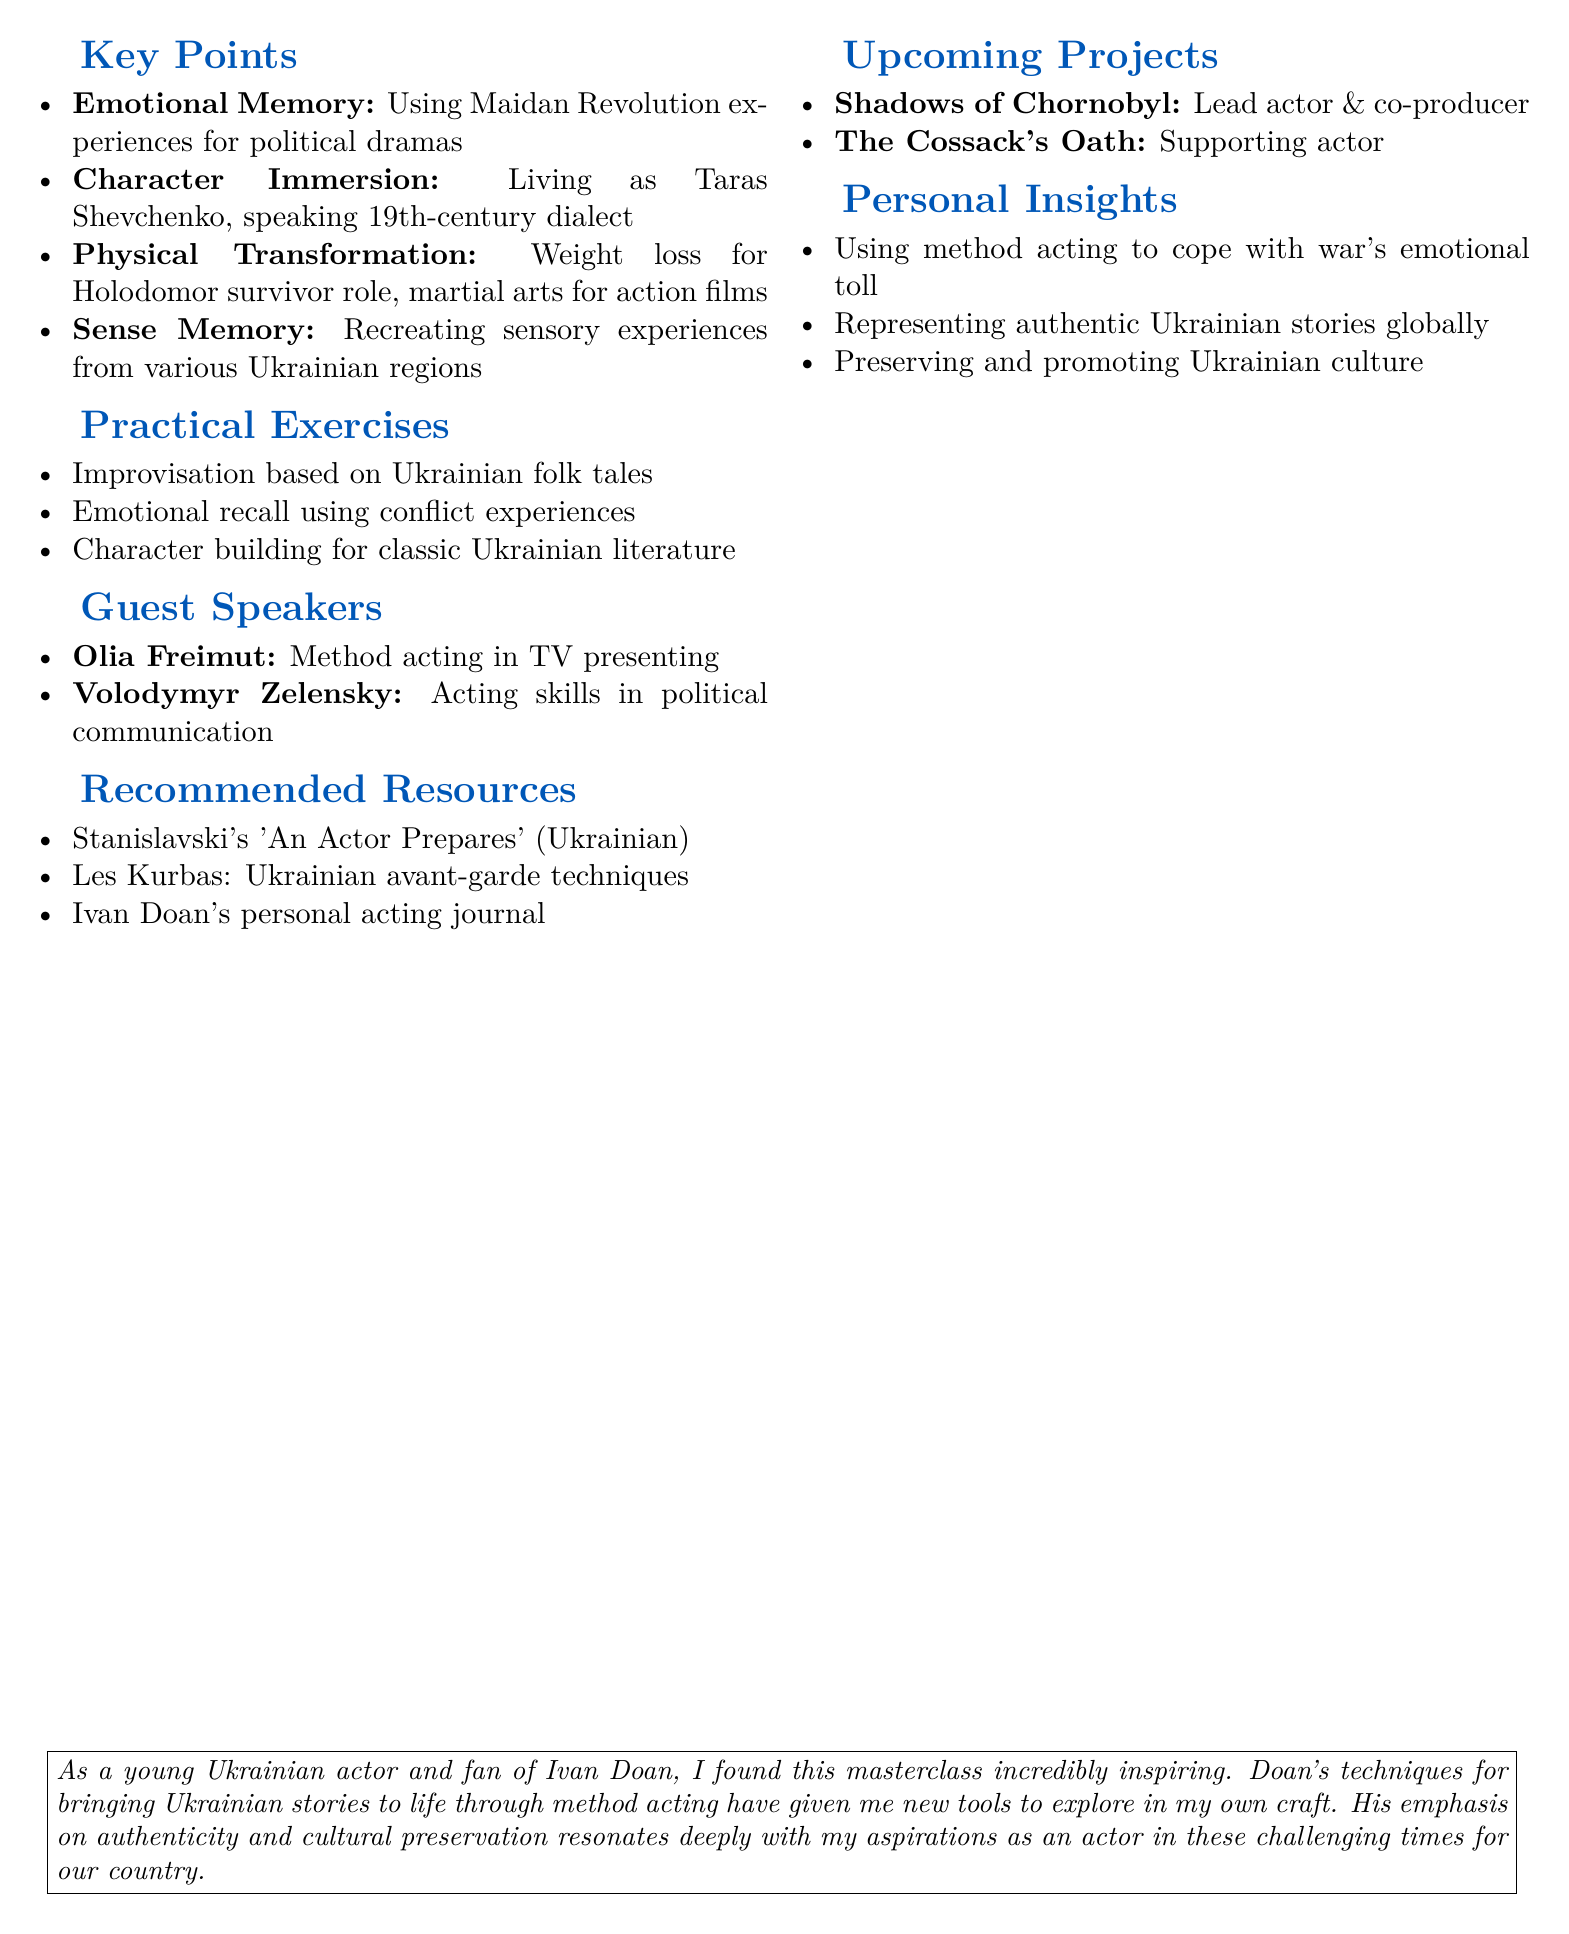What was the date of Ivan Doan's masterclass? The date is specified in the document as May 15, 2023.
Answer: May 15, 2023 Where was the masterclass held? The location is mentioned in the document, specifically stating it was held at the Kyiv National I. K. Karpenko-Kary Theatre, Cinema and Television University.
Answer: Kyiv National I. K. Karpenko-Kary Theatre, Cinema and Television University What is a key point discussed regarding emotional memory techniques? This key point highlights the use of personal experiences, particularly recalling memories from the Maidan Revolution for authenticity in performance.
Answer: Maidan Revolution Who were the guest speakers at the masterclass? The document lists two guest speakers: Olia Freimut and Volodymyr Zelensky.
Answer: Olia Freimut and Volodymyr Zelensky What is one of the practical exercises mentioned? The document includes several practical exercises; one is specified as improvisation scenes based on Ukrainian folk tales.
Answer: Improvisation scenes based on Ukrainian folk tales What upcoming project is Ivan Doan involved in as lead actor? The document notes "Shadows of Chornobyl" as the project he is leading.
Answer: Shadows of Chornobyl What personal insight did Ivan Doan share? The document mentions that he shared his experience of using method acting to cope with the emotional toll of the ongoing war in Ukraine.
Answer: Coping with the emotional toll of the ongoing war in Ukraine 